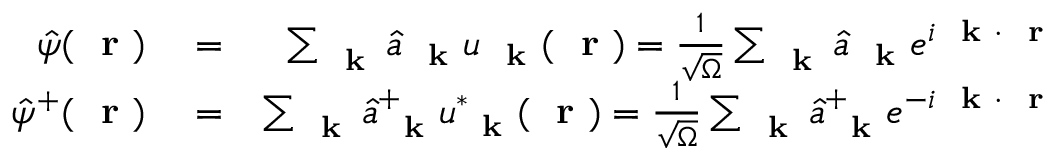<formula> <loc_0><loc_0><loc_500><loc_500>\begin{array} { r l r } { \hat { \psi } ( r ) } & = } & { \sum _ { k } \hat { a } _ { k } u _ { k } ( r ) = \frac { 1 } { \sqrt { \Omega } } \sum _ { k } \hat { a } _ { k } e ^ { i k \cdot r } } \\ { \hat { \psi } ^ { + } ( r ) } & = } & { \sum _ { k } \hat { a } _ { k } ^ { + } u _ { k } ^ { * } ( r ) = \frac { 1 } { \sqrt { \Omega } } \sum _ { k } \hat { a } _ { k } ^ { + } e ^ { - i k \cdot r } } \end{array}</formula> 